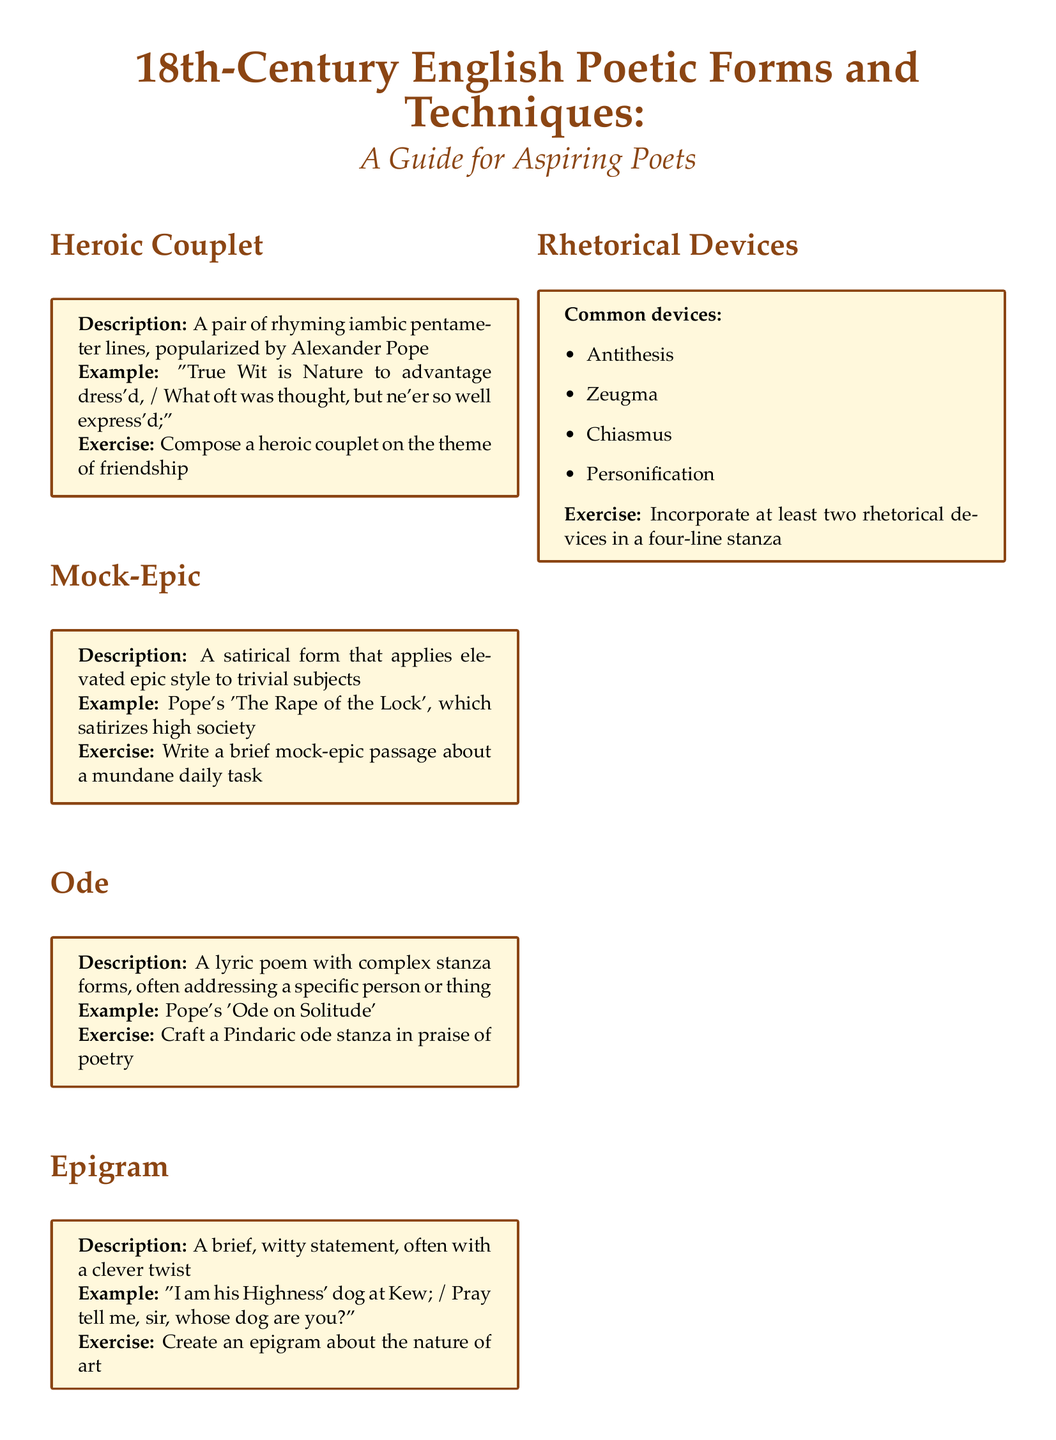What is the name of the poetic form composed of a pair of rhyming lines? The section describes a specific poetic form characterized by two rhyming lines, which is the heroic couplet.
Answer: Heroic Couplet Which Alexander Pope work is cited as an example of a mock-epic? The document provides a specific title of Pope's work that exemplifies a mock-epic, specifically addressing a trivial subject.
Answer: The Rape of the Lock What type of poem is the ode described in the document? The guide defines a specific type of lyric poem, mentioning the complexity in its structure.
Answer: Lyric poem Which rhetorical devices are noted in the document? The section lists specific rhetorical devices, emphasizing their common usage in poetry, including antithesis and others.
Answer: Antithesis, Zeugma, Chiasmus, Personification What is the recommended reading title mentioned first? The document contains a list of recommended readings, with the notable work by Alexander Pope listed first.
Answer: Alexander Pope: Selected Poetry What type of collaborative project is suggested at the end of the document? The document invites readers to engage in a specific type of poetic collaboration, indicating the structure and theme of the project.
Answer: Linked heroic couplets What is the theme for the exercise related to the heroic couplet? The exercise section request participants to write couplets around a theme focusing on a personal connection or value.
Answer: Friendship How many poetic forms are introduced in this document? The document outlines several forms of poetry and techniques, indicating the variation in types presented to the reader.
Answer: Five 